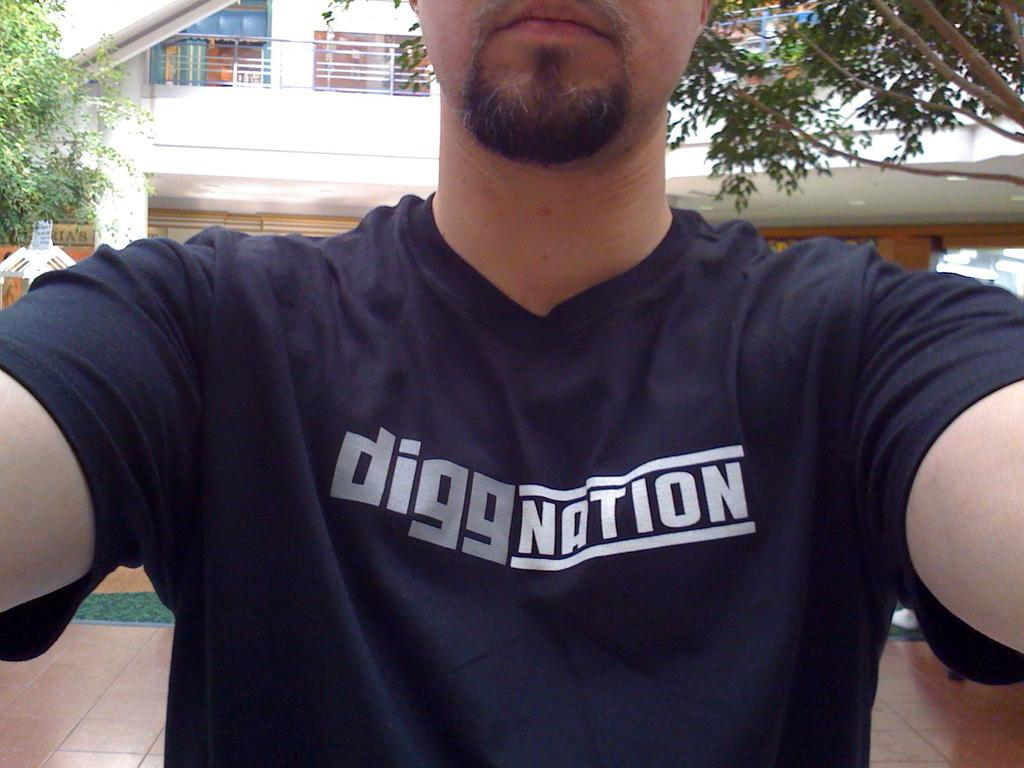What is the main subject in the foreground of the image? There is a man in the foreground of the image. What is the man wearing in the image? The man is wearing a t-shirt in the image. What can be seen on the t-shirt? There is text on the t-shirt. What can be seen in the background of the image? There is a building and trees in the background of the image. Can you hear the caption being read aloud in the image? There is no caption present in the image, and therefore it cannot be heard or read aloud. 